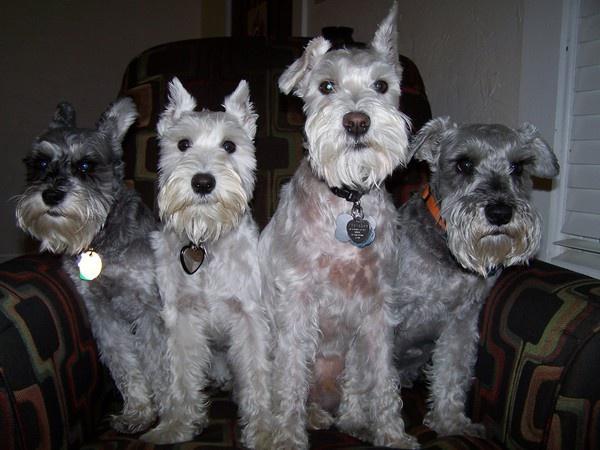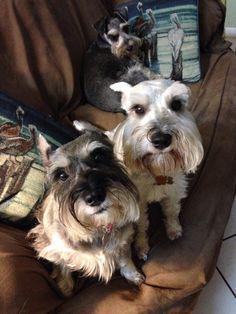The first image is the image on the left, the second image is the image on the right. Evaluate the accuracy of this statement regarding the images: "An image shows at least one schnauzer dog wearing something bright red.". Is it true? Answer yes or no. No. The first image is the image on the left, the second image is the image on the right. For the images displayed, is the sentence "One dog has a red collar in the image on the left." factually correct? Answer yes or no. Yes. 